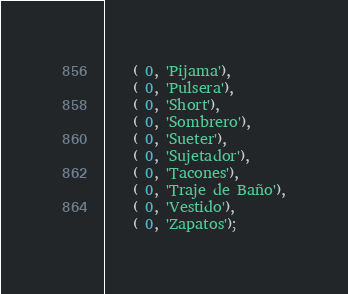Convert code to text. <code><loc_0><loc_0><loc_500><loc_500><_SQL_>    ( 0, 'Pijama'),
    ( 0, 'Pulsera'),
    ( 0, 'Short'),
    ( 0, 'Sombrero'),
    ( 0, 'Sueter'),
    ( 0, 'Sujetador'),
    ( 0, 'Tacones'),
    ( 0, 'Traje de Baño'),
    ( 0, 'Vestido'),
    ( 0, 'Zapatos');</code> 